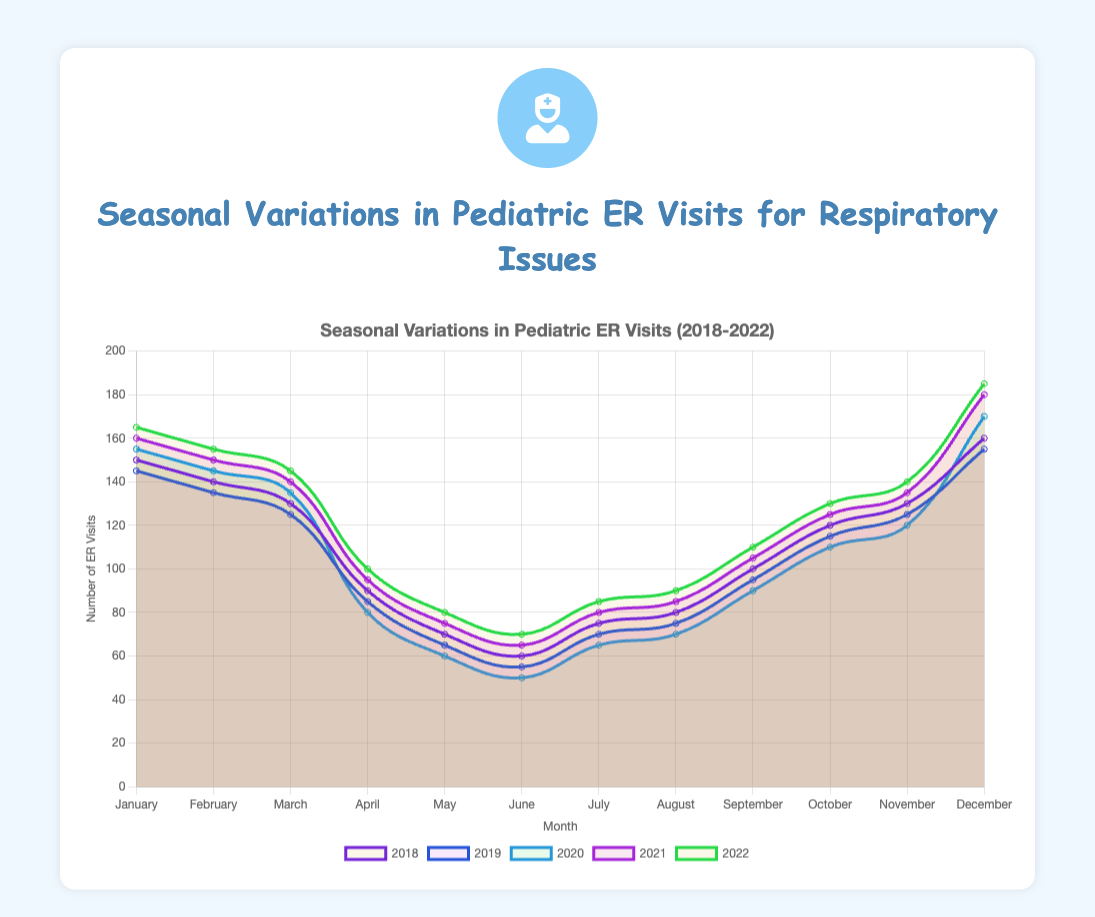Which year had the highest number of ER visits in December? By looking at the December data points for each year, the highest value is found in December 2022 with 185 visits.
Answer: 2022 In which month does the number of ER visits consistently rise for every year? Observing the trends across all years, January consistently shows an increase in ER visits compared to December of the previous year.
Answer: January What is the average number of ER visits for March over the five years? Sum the March visits for each year (130 + 125 + 135 + 140 + 145) = 675, then divide by 5. The average is 675/5 = 135.
Answer: 135 Compare the number of ER visits in June and July for 2018. It can be observed from the plot that in 2018, June had 60 visits and July had 75 visits. Hence, July had more visits than June.
Answer: July Which year shows the smallest peak in ER visits during the summer months (June, July, August)? By analyzing the peaks for each year during June, July, and August, 2020 shows the lowest peak values (June: 50, July: 65, August: 70).
Answer: 2020 What is the difference in pediatric ER visits between February and April in 2021? From the data, the number of visits in February 2021 is 150 and in April 2021 is 95. The difference is 150 - 95 = 55.
Answer: 55 Which month shows the highest variability in ER visits across the five years? By comparing the range (max - min) for each month over the five years, December shows the highest variability ranging from 155 to 185 visits.
Answer: December Calculate the total number of ER visits from May to August in 2019. Summing up the numbers: 65 (May) + 55 (June) + 70 (July) + 75 (August) = 265.
Answer: 265 During which month is the peak ER visit value observed in 2022, and what is the value? The peak in 2022 is observed in December with 185 visits.
Answer: December What can be inferred about the seasonal variation in ER visits for respiratory issues from the plot? Summarizing the trends, it is evident that ER visits are higher in the winter months (December, January, February) and lower in the summer months (June, July, August) across all years shown.
Answer: Higher in winter, lower in summer 